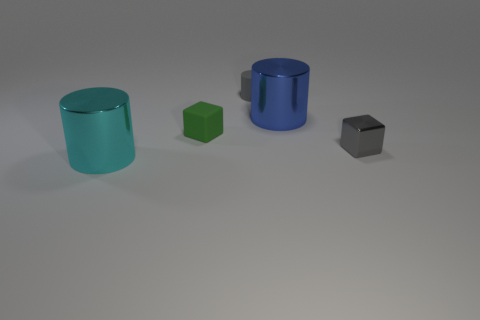Add 2 small purple matte spheres. How many objects exist? 7 Subtract all cubes. How many objects are left? 3 Add 1 green blocks. How many green blocks are left? 2 Add 1 red rubber blocks. How many red rubber blocks exist? 1 Subtract 1 gray blocks. How many objects are left? 4 Subtract all large metal things. Subtract all shiny cylinders. How many objects are left? 1 